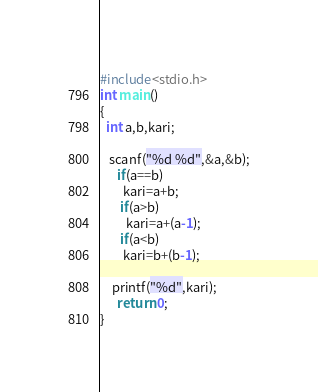Convert code to text. <code><loc_0><loc_0><loc_500><loc_500><_C_>#include<stdio.h>
int main()
{
  int a,b,kari;
  
   scanf("%d %d",&a,&b);
      if(a==b)
        kari=a+b;
       if(a>b)
         kari=a+(a-1); 
       if(a<b)
        kari=b+(b-1);
      
    printf("%d",kari);
      return 0;
}</code> 